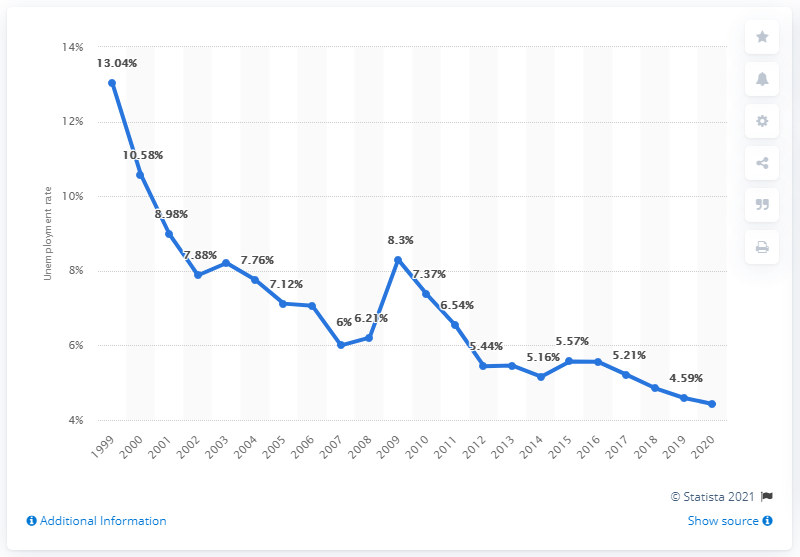Identify some key points in this picture. In 2020, the unemployment rate in Russia was 4.43%. 